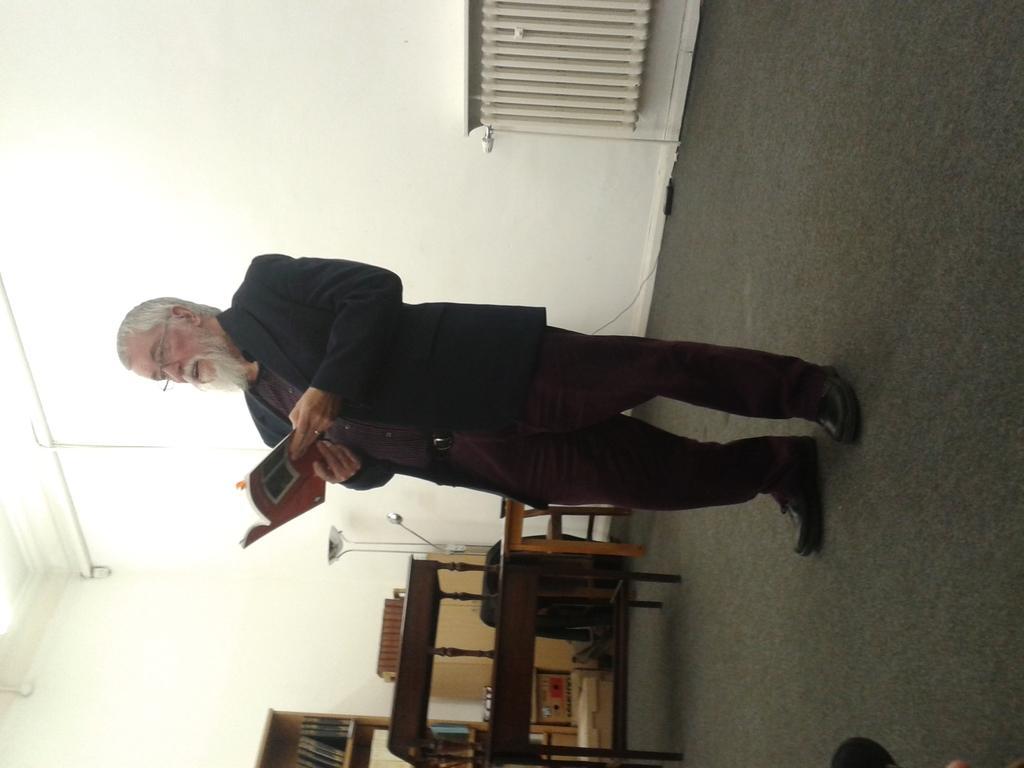Describe this image in one or two sentences. This picture is in left side direction. In this image there is a man standing and holding the book. At the back there are books in the shelf and there is a table and chair and there is an object and there is a cupboard. At the top there is a light. At the bottom there is a mat. On the right side of the image there is an object. 